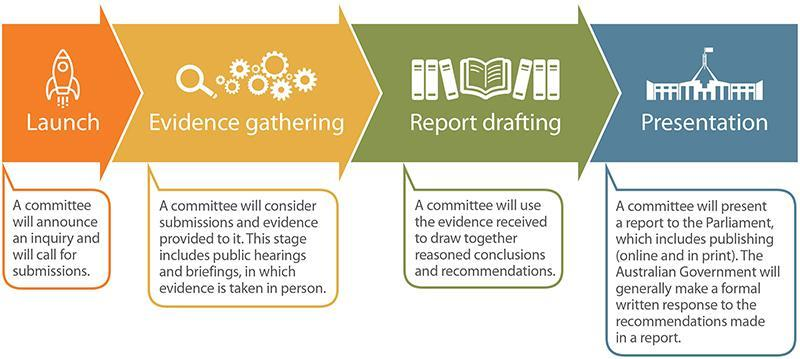what do the files and books represent
Answer the question with a short phrase. report drafting what is the final stage of any report presentation What does the rocket show launch how are the reports presented publishing (online and in print) How are evidence taken in person public hearings and briefings 